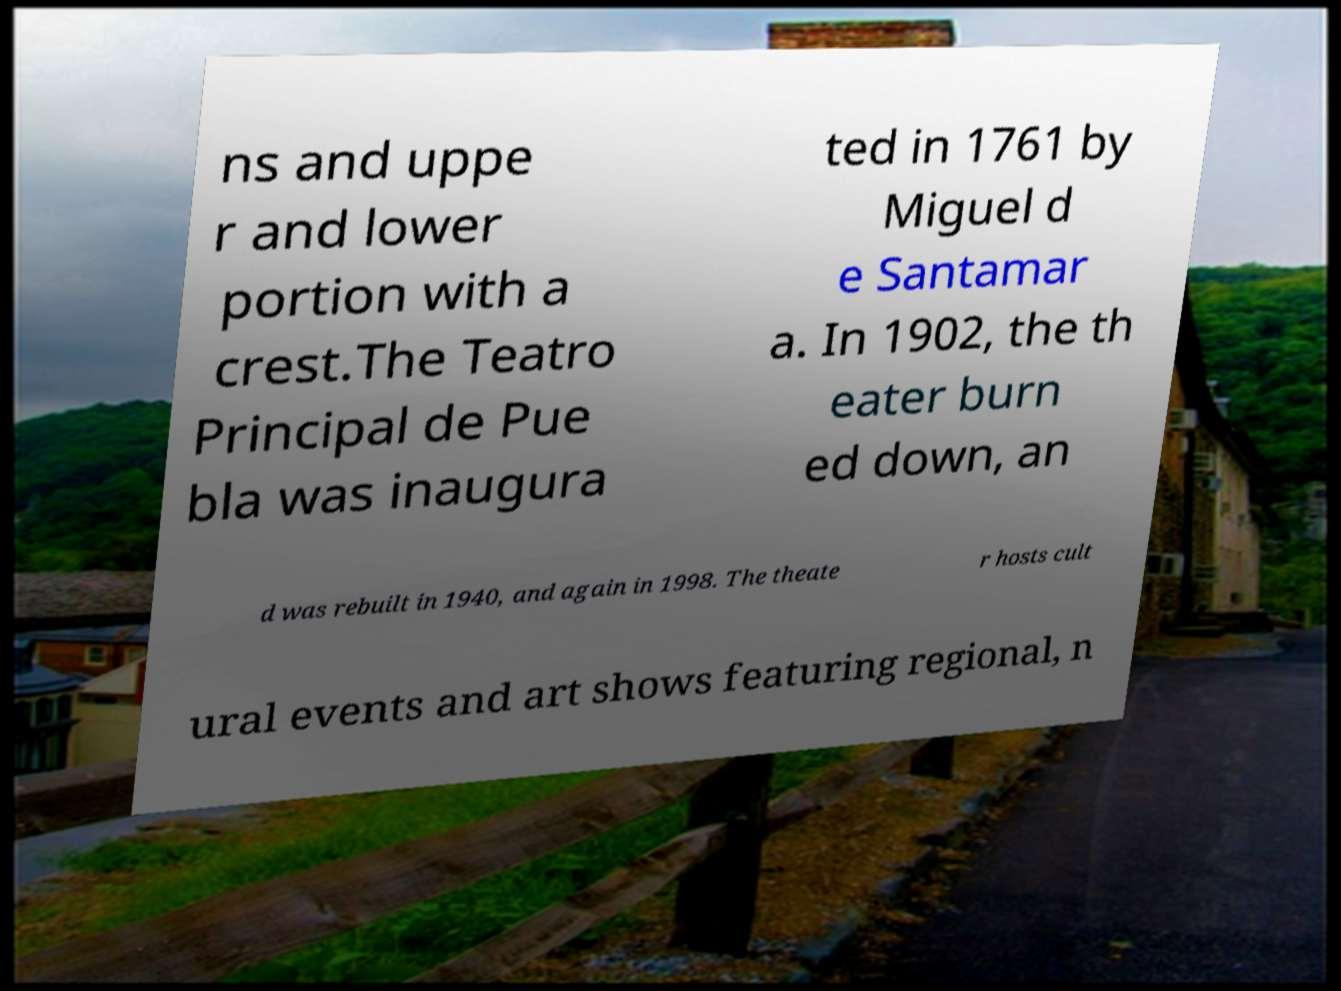Can you read and provide the text displayed in the image?This photo seems to have some interesting text. Can you extract and type it out for me? ns and uppe r and lower portion with a crest.The Teatro Principal de Pue bla was inaugura ted in 1761 by Miguel d e Santamar a. In 1902, the th eater burn ed down, an d was rebuilt in 1940, and again in 1998. The theate r hosts cult ural events and art shows featuring regional, n 